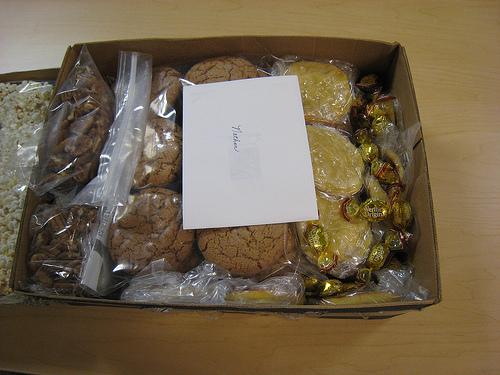<image>
Is the envelope on the cookies? Yes. Looking at the image, I can see the envelope is positioned on top of the cookies, with the cookies providing support. 